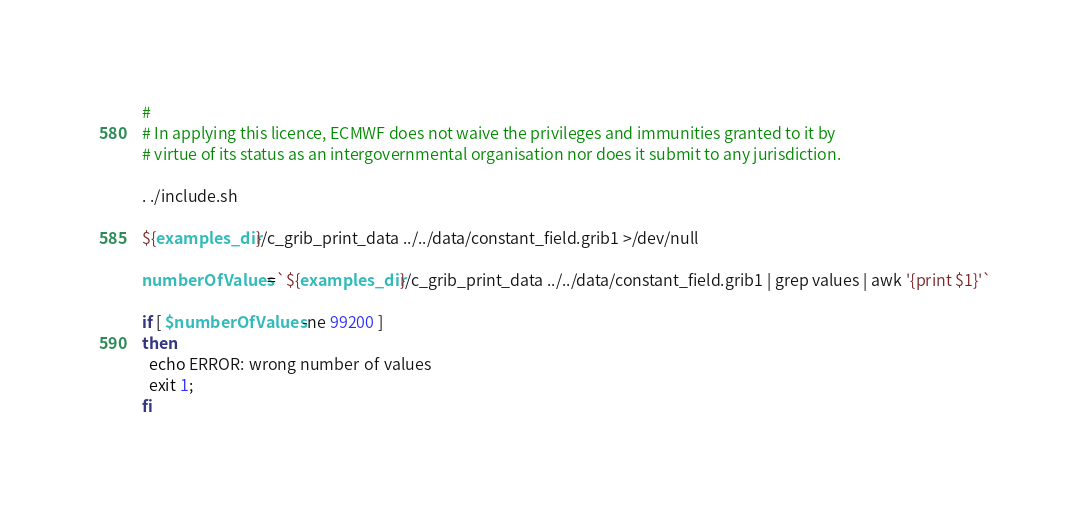Convert code to text. <code><loc_0><loc_0><loc_500><loc_500><_Bash_>#
# In applying this licence, ECMWF does not waive the privileges and immunities granted to it by
# virtue of its status as an intergovernmental organisation nor does it submit to any jurisdiction.

. ./include.sh

${examples_dir}/c_grib_print_data ../../data/constant_field.grib1 >/dev/null

numberOfValues=`${examples_dir}/c_grib_print_data ../../data/constant_field.grib1 | grep values | awk '{print $1}'`

if [ $numberOfValues -ne 99200 ]
then
  echo ERROR: wrong number of values
  exit 1;
fi
</code> 